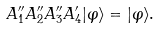Convert formula to latex. <formula><loc_0><loc_0><loc_500><loc_500>A ^ { \prime \prime } _ { 1 } A ^ { \prime \prime } _ { 2 } A ^ { \prime \prime } _ { 3 } A ^ { \prime } _ { 4 } | \varphi \rangle = | \varphi \rangle .</formula> 